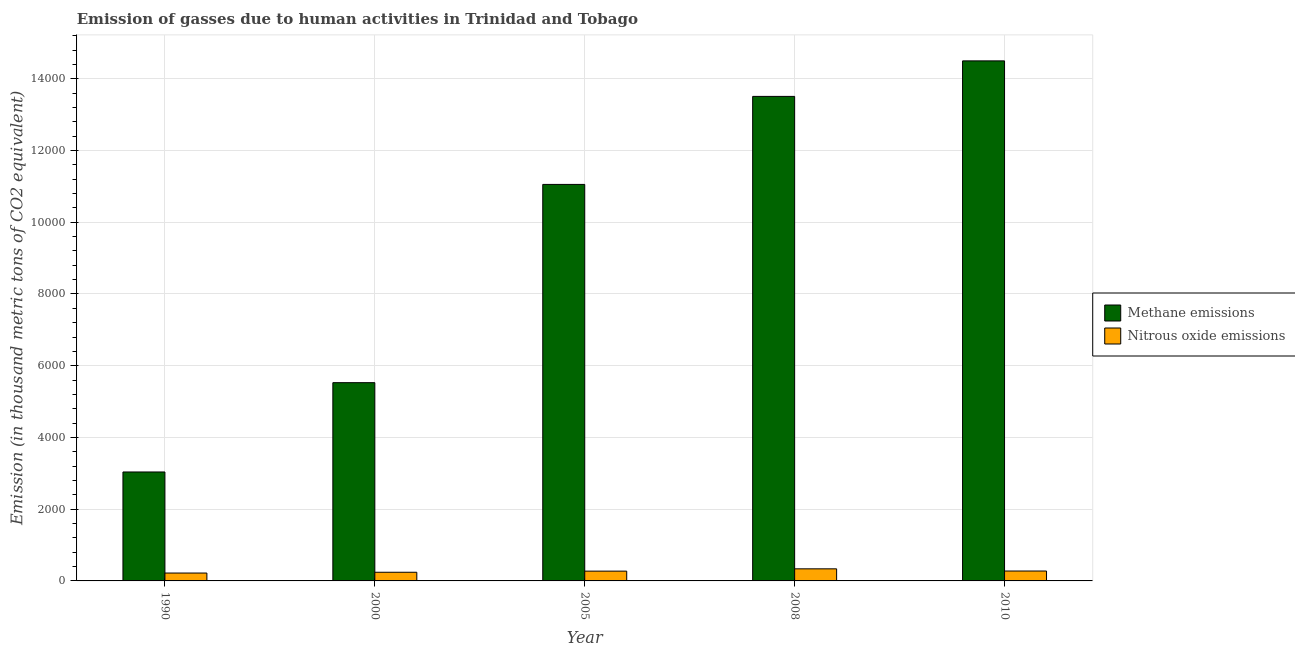In how many cases, is the number of bars for a given year not equal to the number of legend labels?
Offer a very short reply. 0. What is the amount of methane emissions in 2000?
Your response must be concise. 5527.5. Across all years, what is the maximum amount of methane emissions?
Your answer should be very brief. 1.45e+04. Across all years, what is the minimum amount of nitrous oxide emissions?
Your response must be concise. 219.9. In which year was the amount of methane emissions maximum?
Provide a short and direct response. 2010. What is the total amount of nitrous oxide emissions in the graph?
Provide a short and direct response. 1346.8. What is the difference between the amount of methane emissions in 2000 and that in 2008?
Keep it short and to the point. -7981.1. What is the difference between the amount of methane emissions in 1990 and the amount of nitrous oxide emissions in 2005?
Your answer should be very brief. -8017.1. What is the average amount of nitrous oxide emissions per year?
Make the answer very short. 269.36. In the year 2008, what is the difference between the amount of nitrous oxide emissions and amount of methane emissions?
Your response must be concise. 0. In how many years, is the amount of methane emissions greater than 6800 thousand metric tons?
Your answer should be compact. 3. What is the ratio of the amount of methane emissions in 1990 to that in 2010?
Keep it short and to the point. 0.21. What is the difference between the highest and the second highest amount of nitrous oxide emissions?
Give a very brief answer. 61. What is the difference between the highest and the lowest amount of nitrous oxide emissions?
Your answer should be compact. 116.9. In how many years, is the amount of methane emissions greater than the average amount of methane emissions taken over all years?
Keep it short and to the point. 3. Is the sum of the amount of nitrous oxide emissions in 1990 and 2005 greater than the maximum amount of methane emissions across all years?
Offer a terse response. Yes. What does the 2nd bar from the left in 1990 represents?
Provide a succinct answer. Nitrous oxide emissions. What does the 2nd bar from the right in 2010 represents?
Provide a short and direct response. Methane emissions. How many bars are there?
Make the answer very short. 10. How are the legend labels stacked?
Keep it short and to the point. Vertical. What is the title of the graph?
Provide a short and direct response. Emission of gasses due to human activities in Trinidad and Tobago. Does "Fertility rate" appear as one of the legend labels in the graph?
Your response must be concise. No. What is the label or title of the Y-axis?
Offer a very short reply. Emission (in thousand metric tons of CO2 equivalent). What is the Emission (in thousand metric tons of CO2 equivalent) of Methane emissions in 1990?
Make the answer very short. 3037.6. What is the Emission (in thousand metric tons of CO2 equivalent) of Nitrous oxide emissions in 1990?
Your answer should be compact. 219.9. What is the Emission (in thousand metric tons of CO2 equivalent) in Methane emissions in 2000?
Give a very brief answer. 5527.5. What is the Emission (in thousand metric tons of CO2 equivalent) of Nitrous oxide emissions in 2000?
Your answer should be compact. 241.5. What is the Emission (in thousand metric tons of CO2 equivalent) in Methane emissions in 2005?
Ensure brevity in your answer.  1.11e+04. What is the Emission (in thousand metric tons of CO2 equivalent) of Nitrous oxide emissions in 2005?
Give a very brief answer. 272.8. What is the Emission (in thousand metric tons of CO2 equivalent) of Methane emissions in 2008?
Your answer should be compact. 1.35e+04. What is the Emission (in thousand metric tons of CO2 equivalent) of Nitrous oxide emissions in 2008?
Ensure brevity in your answer.  336.8. What is the Emission (in thousand metric tons of CO2 equivalent) of Methane emissions in 2010?
Your response must be concise. 1.45e+04. What is the Emission (in thousand metric tons of CO2 equivalent) of Nitrous oxide emissions in 2010?
Make the answer very short. 275.8. Across all years, what is the maximum Emission (in thousand metric tons of CO2 equivalent) of Methane emissions?
Provide a short and direct response. 1.45e+04. Across all years, what is the maximum Emission (in thousand metric tons of CO2 equivalent) in Nitrous oxide emissions?
Your answer should be very brief. 336.8. Across all years, what is the minimum Emission (in thousand metric tons of CO2 equivalent) of Methane emissions?
Make the answer very short. 3037.6. Across all years, what is the minimum Emission (in thousand metric tons of CO2 equivalent) in Nitrous oxide emissions?
Offer a very short reply. 219.9. What is the total Emission (in thousand metric tons of CO2 equivalent) in Methane emissions in the graph?
Your answer should be very brief. 4.76e+04. What is the total Emission (in thousand metric tons of CO2 equivalent) of Nitrous oxide emissions in the graph?
Offer a terse response. 1346.8. What is the difference between the Emission (in thousand metric tons of CO2 equivalent) in Methane emissions in 1990 and that in 2000?
Keep it short and to the point. -2489.9. What is the difference between the Emission (in thousand metric tons of CO2 equivalent) of Nitrous oxide emissions in 1990 and that in 2000?
Your response must be concise. -21.6. What is the difference between the Emission (in thousand metric tons of CO2 equivalent) in Methane emissions in 1990 and that in 2005?
Give a very brief answer. -8017.1. What is the difference between the Emission (in thousand metric tons of CO2 equivalent) in Nitrous oxide emissions in 1990 and that in 2005?
Provide a succinct answer. -52.9. What is the difference between the Emission (in thousand metric tons of CO2 equivalent) in Methane emissions in 1990 and that in 2008?
Offer a terse response. -1.05e+04. What is the difference between the Emission (in thousand metric tons of CO2 equivalent) of Nitrous oxide emissions in 1990 and that in 2008?
Provide a short and direct response. -116.9. What is the difference between the Emission (in thousand metric tons of CO2 equivalent) in Methane emissions in 1990 and that in 2010?
Your response must be concise. -1.15e+04. What is the difference between the Emission (in thousand metric tons of CO2 equivalent) in Nitrous oxide emissions in 1990 and that in 2010?
Give a very brief answer. -55.9. What is the difference between the Emission (in thousand metric tons of CO2 equivalent) of Methane emissions in 2000 and that in 2005?
Make the answer very short. -5527.2. What is the difference between the Emission (in thousand metric tons of CO2 equivalent) in Nitrous oxide emissions in 2000 and that in 2005?
Offer a very short reply. -31.3. What is the difference between the Emission (in thousand metric tons of CO2 equivalent) in Methane emissions in 2000 and that in 2008?
Ensure brevity in your answer.  -7981.1. What is the difference between the Emission (in thousand metric tons of CO2 equivalent) of Nitrous oxide emissions in 2000 and that in 2008?
Give a very brief answer. -95.3. What is the difference between the Emission (in thousand metric tons of CO2 equivalent) of Methane emissions in 2000 and that in 2010?
Offer a very short reply. -8971.6. What is the difference between the Emission (in thousand metric tons of CO2 equivalent) of Nitrous oxide emissions in 2000 and that in 2010?
Provide a succinct answer. -34.3. What is the difference between the Emission (in thousand metric tons of CO2 equivalent) in Methane emissions in 2005 and that in 2008?
Your response must be concise. -2453.9. What is the difference between the Emission (in thousand metric tons of CO2 equivalent) in Nitrous oxide emissions in 2005 and that in 2008?
Make the answer very short. -64. What is the difference between the Emission (in thousand metric tons of CO2 equivalent) in Methane emissions in 2005 and that in 2010?
Provide a succinct answer. -3444.4. What is the difference between the Emission (in thousand metric tons of CO2 equivalent) in Methane emissions in 2008 and that in 2010?
Provide a succinct answer. -990.5. What is the difference between the Emission (in thousand metric tons of CO2 equivalent) in Methane emissions in 1990 and the Emission (in thousand metric tons of CO2 equivalent) in Nitrous oxide emissions in 2000?
Offer a terse response. 2796.1. What is the difference between the Emission (in thousand metric tons of CO2 equivalent) in Methane emissions in 1990 and the Emission (in thousand metric tons of CO2 equivalent) in Nitrous oxide emissions in 2005?
Provide a succinct answer. 2764.8. What is the difference between the Emission (in thousand metric tons of CO2 equivalent) of Methane emissions in 1990 and the Emission (in thousand metric tons of CO2 equivalent) of Nitrous oxide emissions in 2008?
Your response must be concise. 2700.8. What is the difference between the Emission (in thousand metric tons of CO2 equivalent) in Methane emissions in 1990 and the Emission (in thousand metric tons of CO2 equivalent) in Nitrous oxide emissions in 2010?
Give a very brief answer. 2761.8. What is the difference between the Emission (in thousand metric tons of CO2 equivalent) in Methane emissions in 2000 and the Emission (in thousand metric tons of CO2 equivalent) in Nitrous oxide emissions in 2005?
Give a very brief answer. 5254.7. What is the difference between the Emission (in thousand metric tons of CO2 equivalent) in Methane emissions in 2000 and the Emission (in thousand metric tons of CO2 equivalent) in Nitrous oxide emissions in 2008?
Offer a terse response. 5190.7. What is the difference between the Emission (in thousand metric tons of CO2 equivalent) of Methane emissions in 2000 and the Emission (in thousand metric tons of CO2 equivalent) of Nitrous oxide emissions in 2010?
Keep it short and to the point. 5251.7. What is the difference between the Emission (in thousand metric tons of CO2 equivalent) in Methane emissions in 2005 and the Emission (in thousand metric tons of CO2 equivalent) in Nitrous oxide emissions in 2008?
Offer a terse response. 1.07e+04. What is the difference between the Emission (in thousand metric tons of CO2 equivalent) in Methane emissions in 2005 and the Emission (in thousand metric tons of CO2 equivalent) in Nitrous oxide emissions in 2010?
Offer a very short reply. 1.08e+04. What is the difference between the Emission (in thousand metric tons of CO2 equivalent) in Methane emissions in 2008 and the Emission (in thousand metric tons of CO2 equivalent) in Nitrous oxide emissions in 2010?
Make the answer very short. 1.32e+04. What is the average Emission (in thousand metric tons of CO2 equivalent) in Methane emissions per year?
Provide a succinct answer. 9525.5. What is the average Emission (in thousand metric tons of CO2 equivalent) of Nitrous oxide emissions per year?
Offer a very short reply. 269.36. In the year 1990, what is the difference between the Emission (in thousand metric tons of CO2 equivalent) in Methane emissions and Emission (in thousand metric tons of CO2 equivalent) in Nitrous oxide emissions?
Offer a very short reply. 2817.7. In the year 2000, what is the difference between the Emission (in thousand metric tons of CO2 equivalent) of Methane emissions and Emission (in thousand metric tons of CO2 equivalent) of Nitrous oxide emissions?
Your response must be concise. 5286. In the year 2005, what is the difference between the Emission (in thousand metric tons of CO2 equivalent) in Methane emissions and Emission (in thousand metric tons of CO2 equivalent) in Nitrous oxide emissions?
Offer a very short reply. 1.08e+04. In the year 2008, what is the difference between the Emission (in thousand metric tons of CO2 equivalent) of Methane emissions and Emission (in thousand metric tons of CO2 equivalent) of Nitrous oxide emissions?
Your answer should be very brief. 1.32e+04. In the year 2010, what is the difference between the Emission (in thousand metric tons of CO2 equivalent) in Methane emissions and Emission (in thousand metric tons of CO2 equivalent) in Nitrous oxide emissions?
Make the answer very short. 1.42e+04. What is the ratio of the Emission (in thousand metric tons of CO2 equivalent) in Methane emissions in 1990 to that in 2000?
Your response must be concise. 0.55. What is the ratio of the Emission (in thousand metric tons of CO2 equivalent) of Nitrous oxide emissions in 1990 to that in 2000?
Your response must be concise. 0.91. What is the ratio of the Emission (in thousand metric tons of CO2 equivalent) of Methane emissions in 1990 to that in 2005?
Offer a very short reply. 0.27. What is the ratio of the Emission (in thousand metric tons of CO2 equivalent) in Nitrous oxide emissions in 1990 to that in 2005?
Keep it short and to the point. 0.81. What is the ratio of the Emission (in thousand metric tons of CO2 equivalent) of Methane emissions in 1990 to that in 2008?
Your response must be concise. 0.22. What is the ratio of the Emission (in thousand metric tons of CO2 equivalent) in Nitrous oxide emissions in 1990 to that in 2008?
Make the answer very short. 0.65. What is the ratio of the Emission (in thousand metric tons of CO2 equivalent) of Methane emissions in 1990 to that in 2010?
Provide a short and direct response. 0.21. What is the ratio of the Emission (in thousand metric tons of CO2 equivalent) of Nitrous oxide emissions in 1990 to that in 2010?
Give a very brief answer. 0.8. What is the ratio of the Emission (in thousand metric tons of CO2 equivalent) of Nitrous oxide emissions in 2000 to that in 2005?
Your answer should be compact. 0.89. What is the ratio of the Emission (in thousand metric tons of CO2 equivalent) in Methane emissions in 2000 to that in 2008?
Provide a short and direct response. 0.41. What is the ratio of the Emission (in thousand metric tons of CO2 equivalent) of Nitrous oxide emissions in 2000 to that in 2008?
Make the answer very short. 0.72. What is the ratio of the Emission (in thousand metric tons of CO2 equivalent) of Methane emissions in 2000 to that in 2010?
Provide a succinct answer. 0.38. What is the ratio of the Emission (in thousand metric tons of CO2 equivalent) in Nitrous oxide emissions in 2000 to that in 2010?
Ensure brevity in your answer.  0.88. What is the ratio of the Emission (in thousand metric tons of CO2 equivalent) in Methane emissions in 2005 to that in 2008?
Your answer should be very brief. 0.82. What is the ratio of the Emission (in thousand metric tons of CO2 equivalent) of Nitrous oxide emissions in 2005 to that in 2008?
Your response must be concise. 0.81. What is the ratio of the Emission (in thousand metric tons of CO2 equivalent) in Methane emissions in 2005 to that in 2010?
Offer a terse response. 0.76. What is the ratio of the Emission (in thousand metric tons of CO2 equivalent) in Methane emissions in 2008 to that in 2010?
Ensure brevity in your answer.  0.93. What is the ratio of the Emission (in thousand metric tons of CO2 equivalent) in Nitrous oxide emissions in 2008 to that in 2010?
Make the answer very short. 1.22. What is the difference between the highest and the second highest Emission (in thousand metric tons of CO2 equivalent) of Methane emissions?
Provide a short and direct response. 990.5. What is the difference between the highest and the lowest Emission (in thousand metric tons of CO2 equivalent) of Methane emissions?
Provide a short and direct response. 1.15e+04. What is the difference between the highest and the lowest Emission (in thousand metric tons of CO2 equivalent) of Nitrous oxide emissions?
Offer a very short reply. 116.9. 